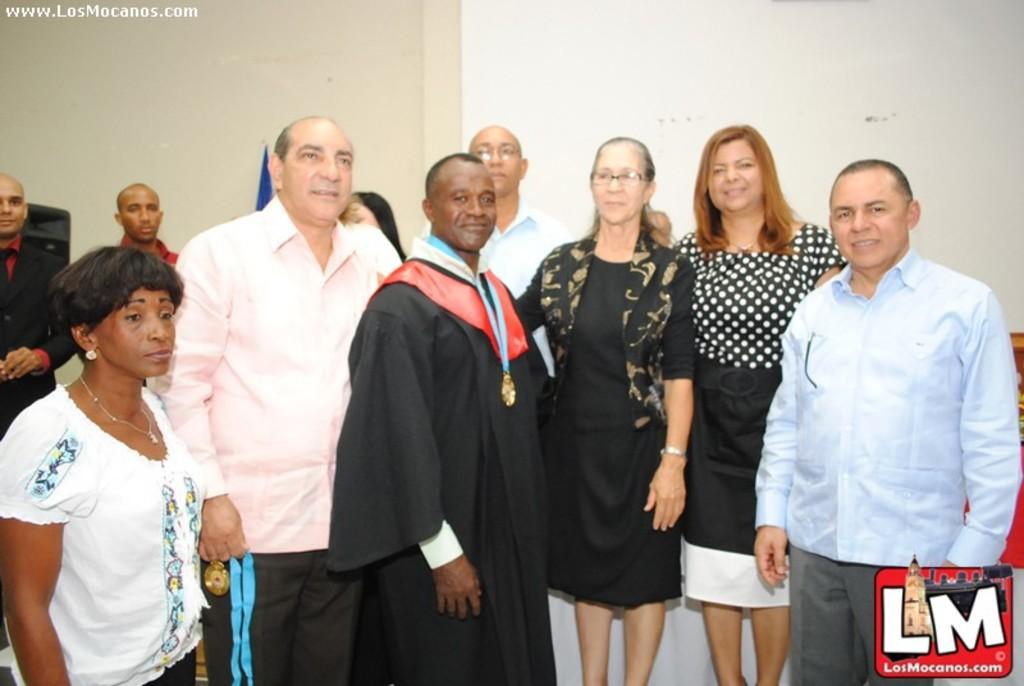How many people are in the image? There are people in the image, but the exact number is not specified. What is one person doing with the medal? One person is holding a medal in the image. What type of structure is visible in the image? There is a wall in the image. What can be read or seen in the form of written words in the image? There is text visible in the image. What type of quilt is being used to cover the chicken in the image? There is no quilt or chicken present in the image. How is the oatmeal being served in the image? There is no oatmeal present in the image. 